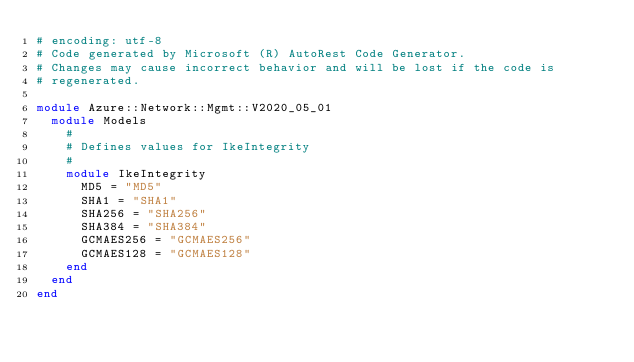Convert code to text. <code><loc_0><loc_0><loc_500><loc_500><_Ruby_># encoding: utf-8
# Code generated by Microsoft (R) AutoRest Code Generator.
# Changes may cause incorrect behavior and will be lost if the code is
# regenerated.

module Azure::Network::Mgmt::V2020_05_01
  module Models
    #
    # Defines values for IkeIntegrity
    #
    module IkeIntegrity
      MD5 = "MD5"
      SHA1 = "SHA1"
      SHA256 = "SHA256"
      SHA384 = "SHA384"
      GCMAES256 = "GCMAES256"
      GCMAES128 = "GCMAES128"
    end
  end
end
</code> 